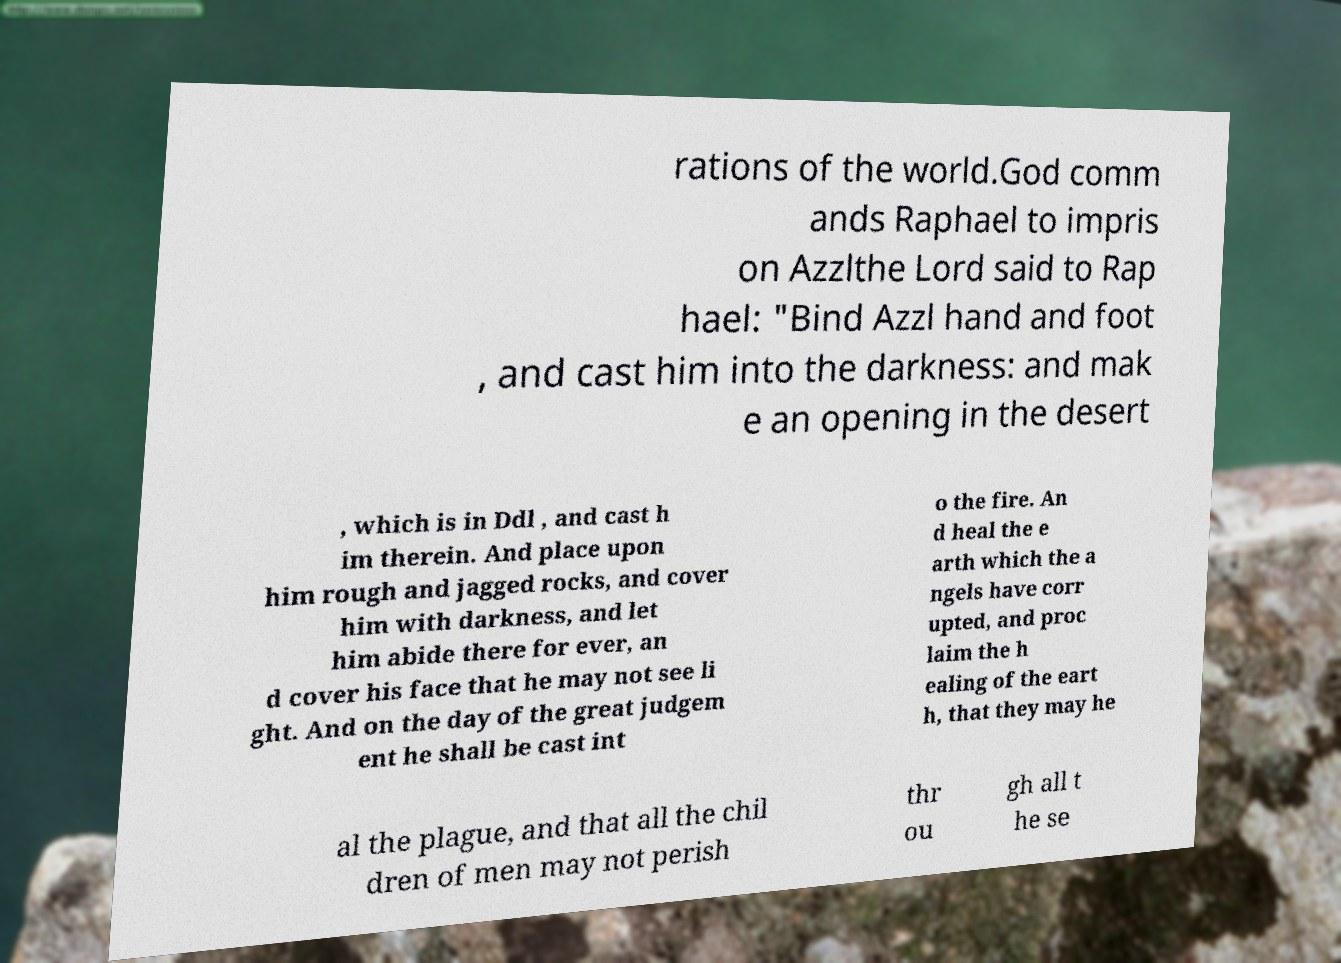Please read and relay the text visible in this image. What does it say? rations of the world.God comm ands Raphael to impris on Azzlthe Lord said to Rap hael: "Bind Azzl hand and foot , and cast him into the darkness: and mak e an opening in the desert , which is in Ddl , and cast h im therein. And place upon him rough and jagged rocks, and cover him with darkness, and let him abide there for ever, an d cover his face that he may not see li ght. And on the day of the great judgem ent he shall be cast int o the fire. An d heal the e arth which the a ngels have corr upted, and proc laim the h ealing of the eart h, that they may he al the plague, and that all the chil dren of men may not perish thr ou gh all t he se 